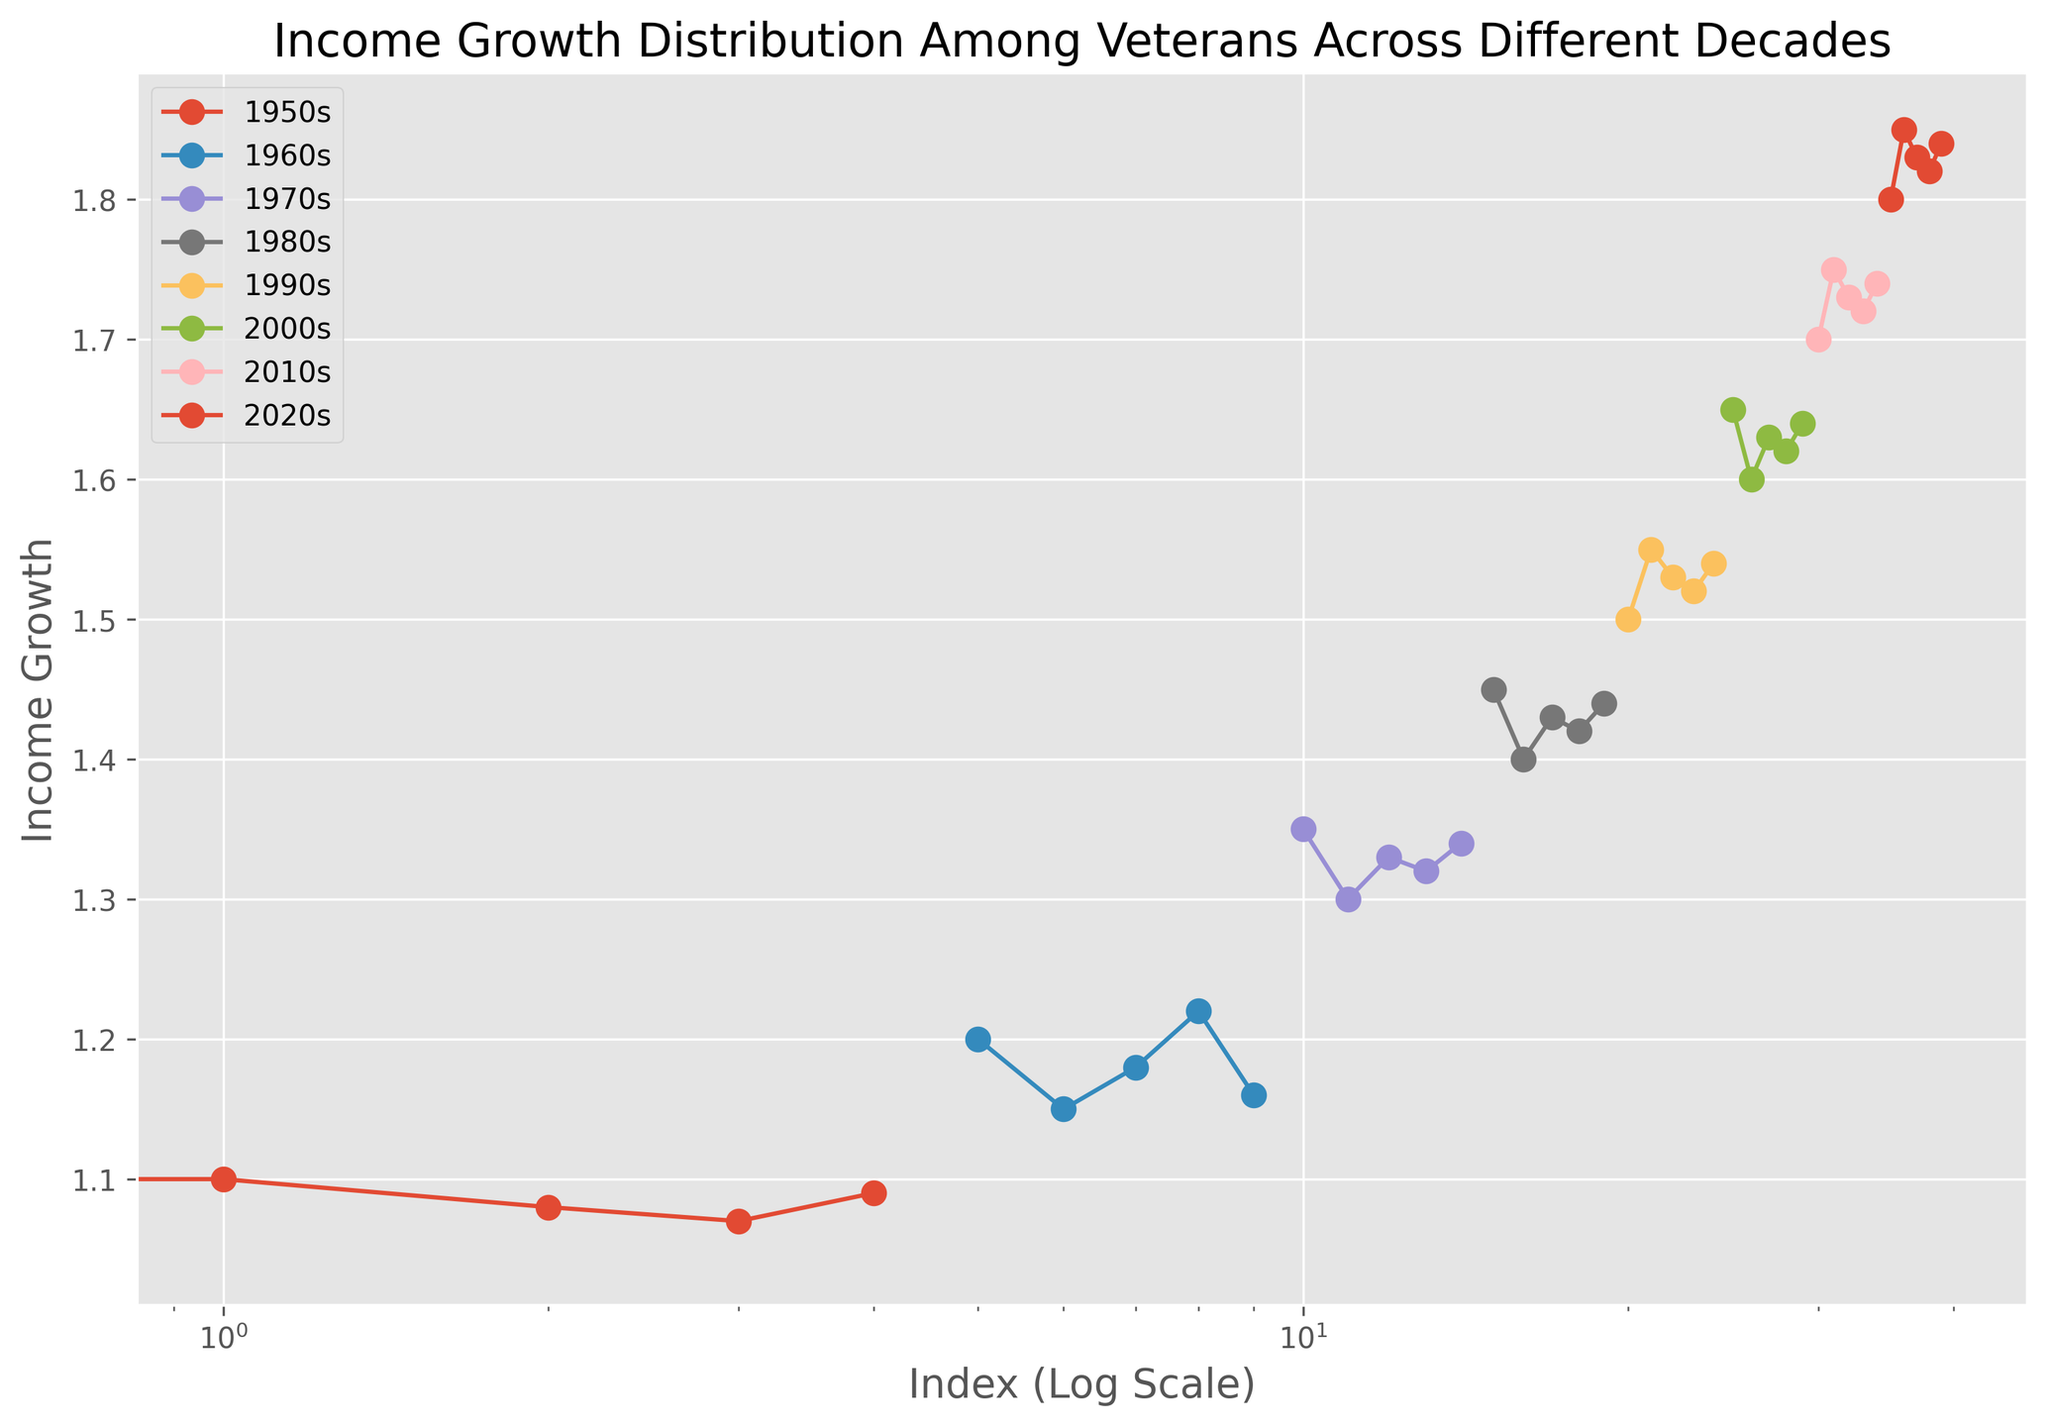Which decade shows the highest median income growth? The median income growth for each decade can be found by ranking the data points for each decade and selecting the middle value. For the 1950s, the median is 1.08; for the 1960s, it is 1.18; for the 1970s, it is 1.33; for the 1980s, it is 1.43; for the 1990s, it is 1.53; for the 2000s, it is 1.63; for the 2010s, it is 1.73; for the 2020s, it is 1.83. Therefore, the highest median income growth is in the 2020s.
Answer: 2020s How does the income growth range of veterans in the 1980s compare to that in the 2000s? The income growth range is the difference between the highest and lowest values. For the 1980s, the range is 1.45 - 1.40 = 0.05. For the 2000s, the range is 1.65 - 1.60 = 0.05. Both decades have the same income growth range of 0.05.
Answer: They are equal Which decade had the lowest minimum income growth? To find the lowest minimum income growth, we compare the lowest values in each decade. The lowest values are: 1950s: 1.05, 1960s: 1.15, 1970s: 1.30, 1980s: 1.40, 1990s: 1.50, 2000s: 1.60, 2010s: 1.70, 2020s: 1.80. The lowest is in the 1950s.
Answer: 1950s What decade shows the greatest variability in income growth? Variability can be assessed by looking at the spread of the data points. The wider the spread between the maximum and minimum values, the greater the variability. The spreads are: 1950s: 1.10 - 1.05 = 0.05, 1960s: 1.22 - 1.15 = 0.07, 1970s: 1.35 - 1.30 = 0.05, 1980s: 1.45 - 1.40 = 0.05, 1990s: 1.55 - 1.50 = 0.05, 2000s: 1.65 - 1.60 = 0.05, 2010s: 1.75 - 1.70 = 0.05, 2020s: 1.85 - 1.80 = 0.05. The decade with the greatest variability is the 1960s.
Answer: 1960s Are there any decades where income growth consistently increased every year? To determine this, we look at the trend line for each decade. None of the decades show a perfect increasing trend every year; instead, some years either remain constant or have slight decreases. Therefore, no decade has a consistent increase in income growth every year.
Answer: No 